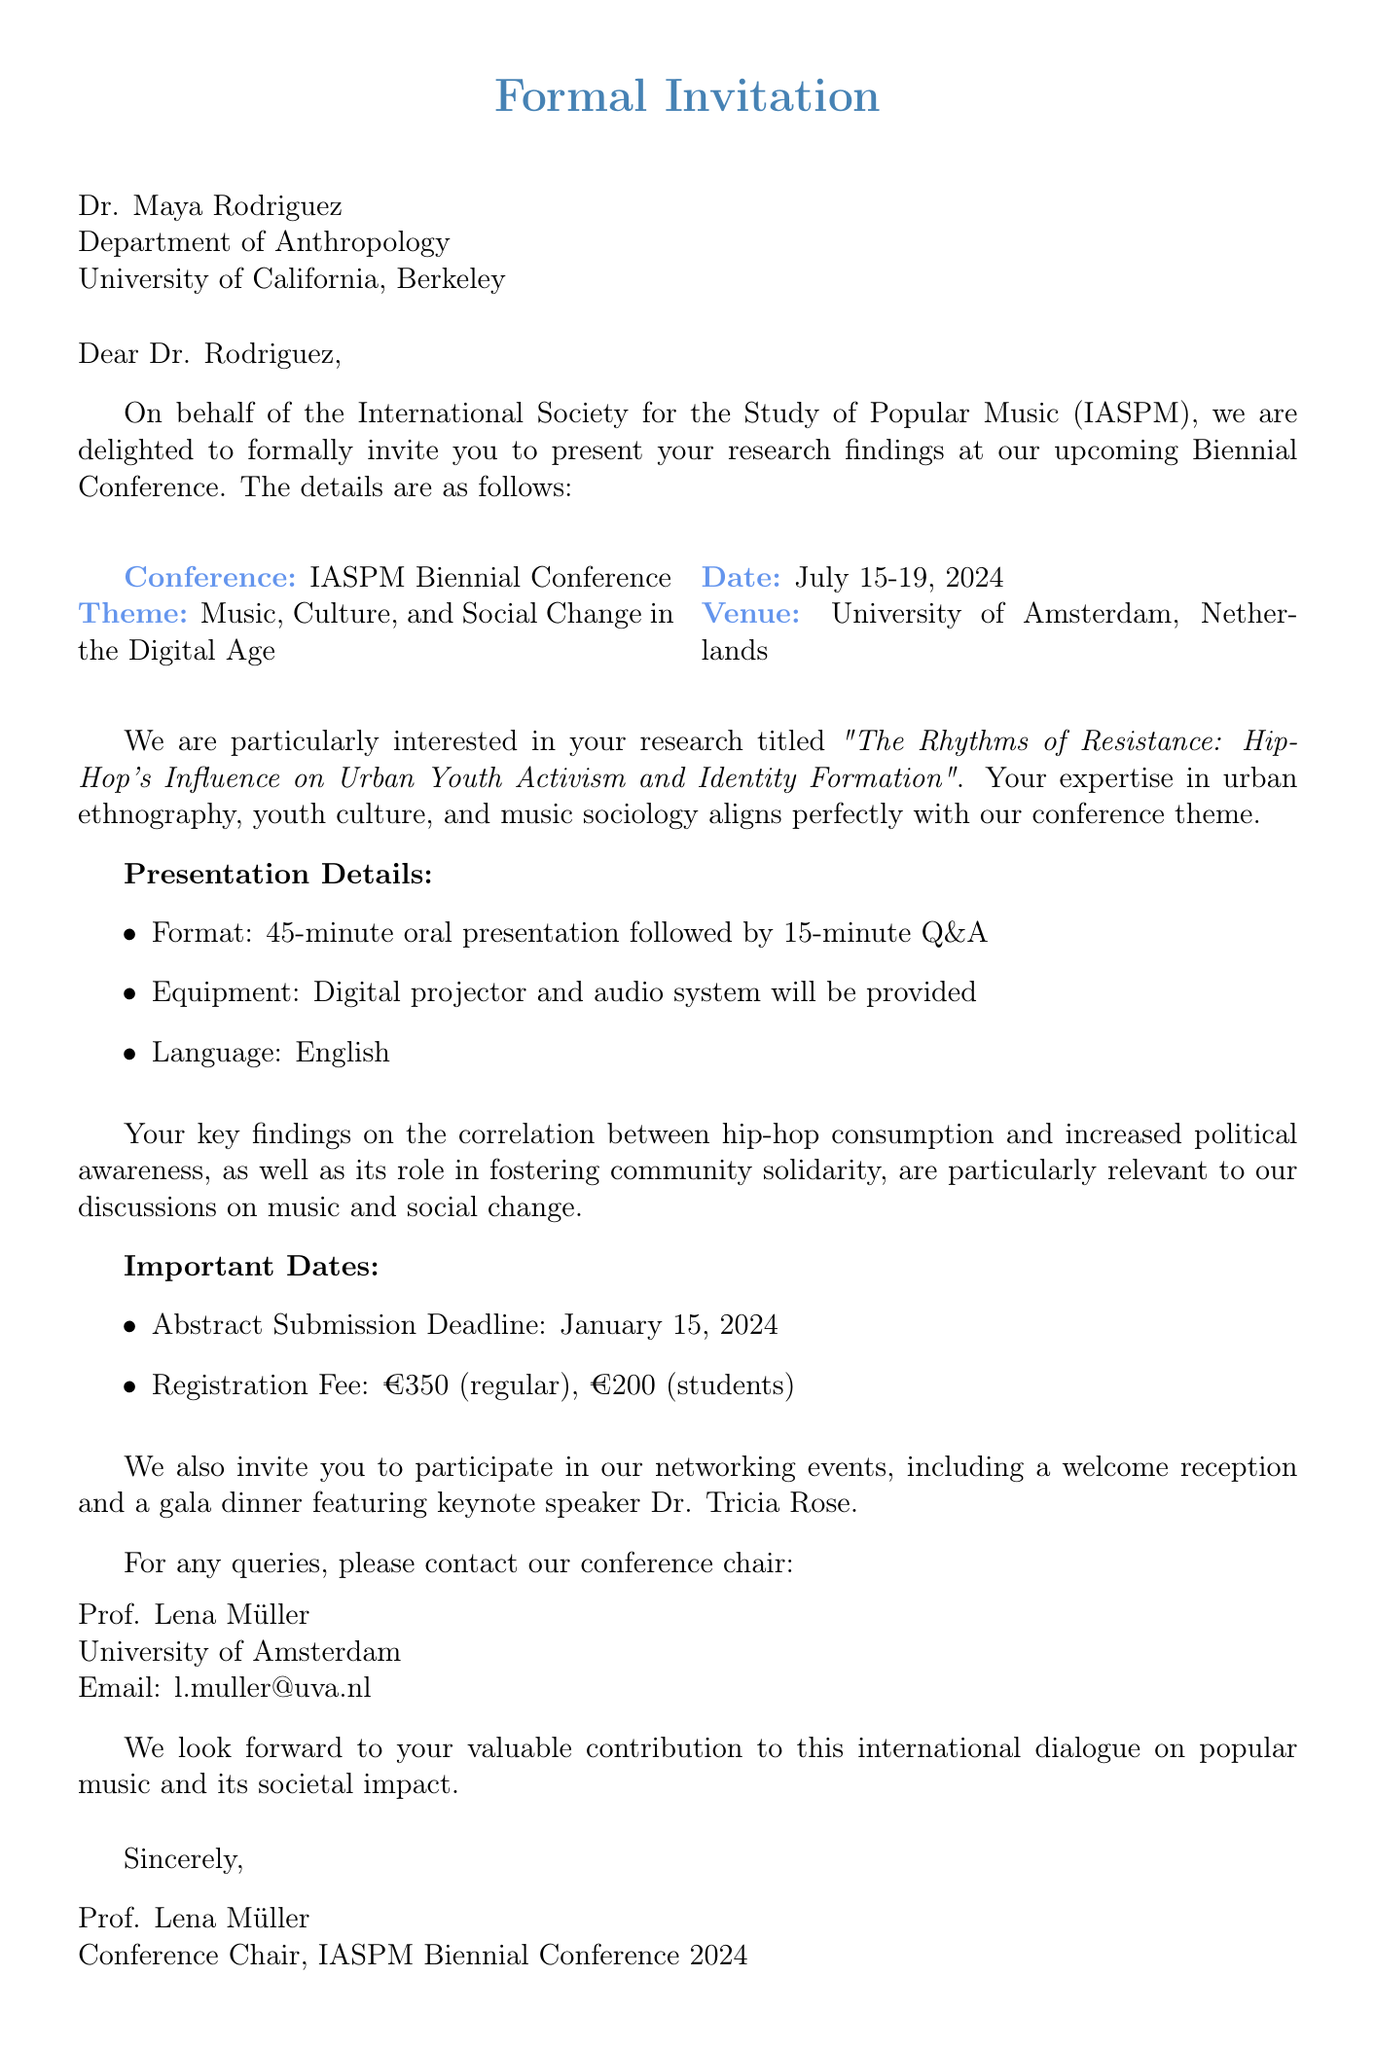What is the name of the conference? The name of the conference is mentioned in the invitation as the International Society for the Study of Popular Music (IASPM) Biennial Conference.
Answer: IASPM Biennial Conference When is the abstract submission deadline? The abstract submission deadline is specified in the document under important dates.
Answer: January 15, 2024 Who is invited to present at the conference? The document indicates that Dr. Maya Rodriguez is invited to present.
Answer: Dr. Maya Rodriguez What is the theme of the conference? The theme is outlined in the document as relating to music and social change in the digital age.
Answer: Music, Culture, and Social Change in the Digital Age What is the registration fee for regular attendees? The registration fee for regular attendees is listed in the additional information section.
Answer: €350 What type of presentation format is requested? The format for the presentation is clearly specified in the presentation details section.
Answer: 45-minute oral presentation followed by 15-minute Q&A Who is the keynote speaker at the gala dinner? The document mentions that Dr. Tricia Rose is the keynote speaker at the gala dinner.
Answer: Dr. Tricia Rose What research topic is Dr. Maya Rodriguez presenting? The research topic she is presenting is given in the document.
Answer: The Rhythms of Resistance: Hip-Hop's Influence on Urban Youth Activism and Identity Formation What institution is Professor Lena Müller associated with? The document specifies that she is associated with the University of Amsterdam.
Answer: University of Amsterdam 